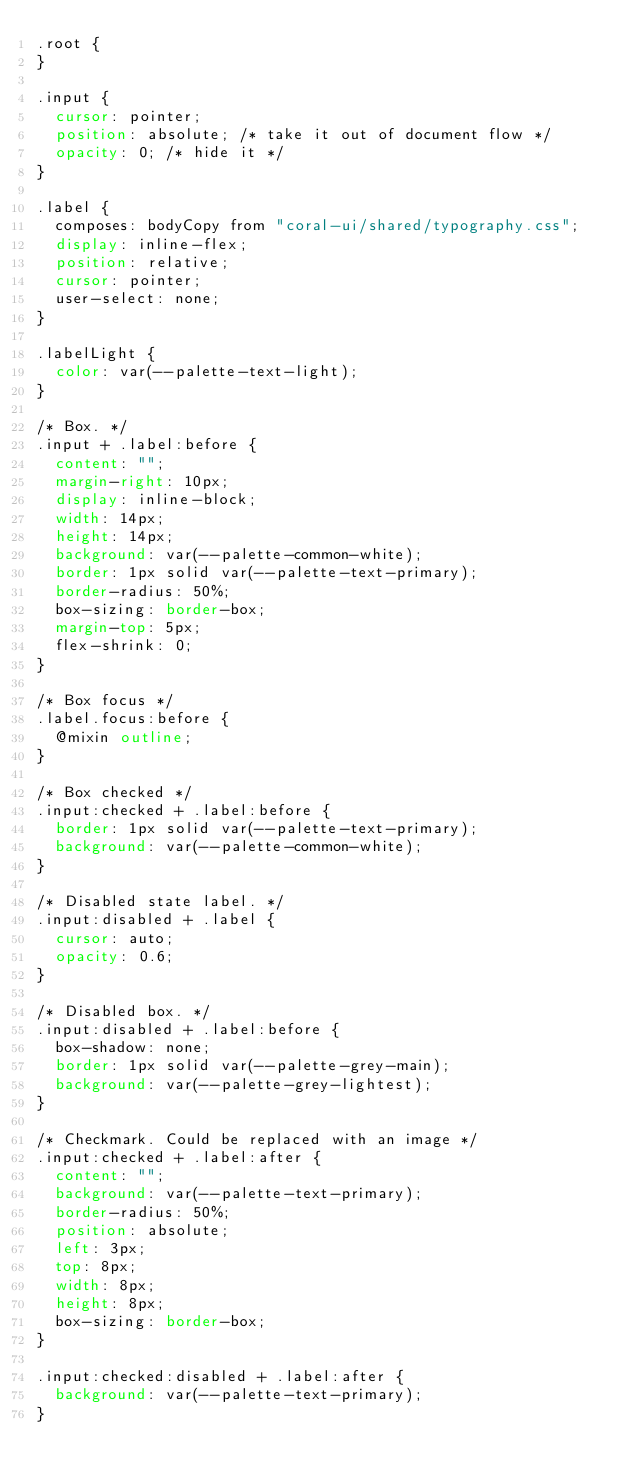<code> <loc_0><loc_0><loc_500><loc_500><_CSS_>.root {
}

.input {
  cursor: pointer;
  position: absolute; /* take it out of document flow */
  opacity: 0; /* hide it */
}

.label {
  composes: bodyCopy from "coral-ui/shared/typography.css";
  display: inline-flex;
  position: relative;
  cursor: pointer;
  user-select: none;
}

.labelLight {
  color: var(--palette-text-light);
}

/* Box. */
.input + .label:before {
  content: "";
  margin-right: 10px;
  display: inline-block;
  width: 14px;
  height: 14px;
  background: var(--palette-common-white);
  border: 1px solid var(--palette-text-primary);
  border-radius: 50%;
  box-sizing: border-box;
  margin-top: 5px;
  flex-shrink: 0;
}

/* Box focus */
.label.focus:before {
  @mixin outline;
}

/* Box checked */
.input:checked + .label:before {
  border: 1px solid var(--palette-text-primary);
  background: var(--palette-common-white);
}

/* Disabled state label. */
.input:disabled + .label {
  cursor: auto;
  opacity: 0.6;
}

/* Disabled box. */
.input:disabled + .label:before {
  box-shadow: none;
  border: 1px solid var(--palette-grey-main);
  background: var(--palette-grey-lightest);
}

/* Checkmark. Could be replaced with an image */
.input:checked + .label:after {
  content: "";
  background: var(--palette-text-primary);
  border-radius: 50%;
  position: absolute;
  left: 3px;
  top: 8px;
  width: 8px;
  height: 8px;
  box-sizing: border-box;
}

.input:checked:disabled + .label:after {
  background: var(--palette-text-primary);
}
</code> 